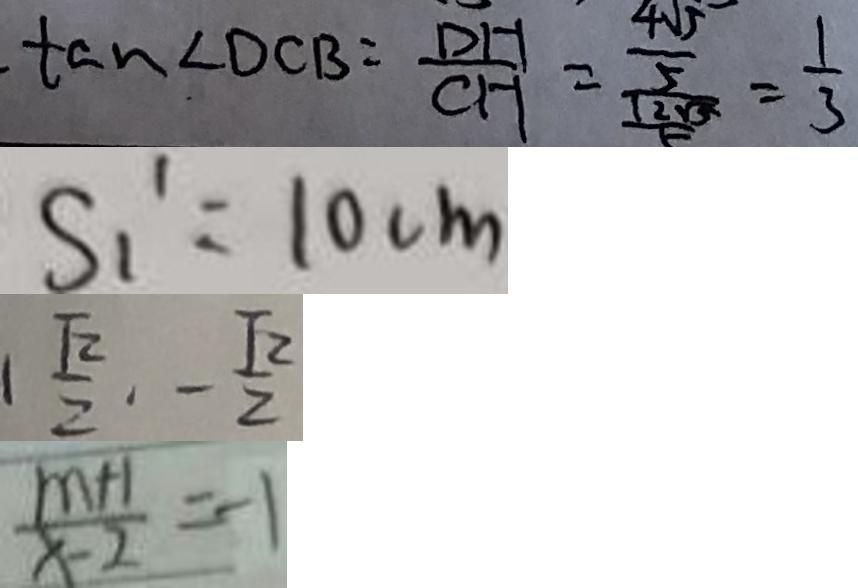<formula> <loc_0><loc_0><loc_500><loc_500>\tan \angle D C B = \frac { D H } { C H } = \frac { \frac { 4 \sqrt { 5 } } { 5 } } { \frac { 1 2 \sqrt { 5 } } { 5 } } = \frac { 1 } { 3 } 
 S _ { 1 } ^ { \prime } = 1 0 c m 
 1 \frac { \sqrt { 2 } } { 2 } \cdot - \frac { \sqrt { 2 } } { 2 } 
 \frac { m + 1 } { x - 2 } = - 1</formula> 